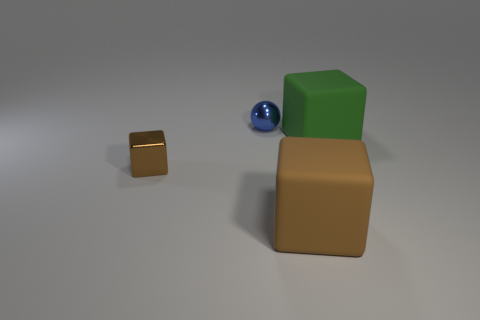Add 2 red matte blocks. How many objects exist? 6 Subtract all cubes. How many objects are left? 1 Subtract all small gray matte spheres. Subtract all large green things. How many objects are left? 3 Add 4 big green matte objects. How many big green matte objects are left? 5 Add 1 tiny purple cubes. How many tiny purple cubes exist? 1 Subtract 0 green cylinders. How many objects are left? 4 